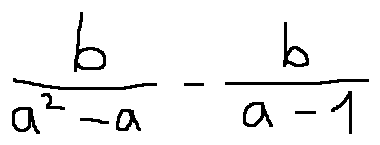<formula> <loc_0><loc_0><loc_500><loc_500>\frac { b } { a ^ { 2 } - a } - \frac { b } { a - 1 }</formula> 